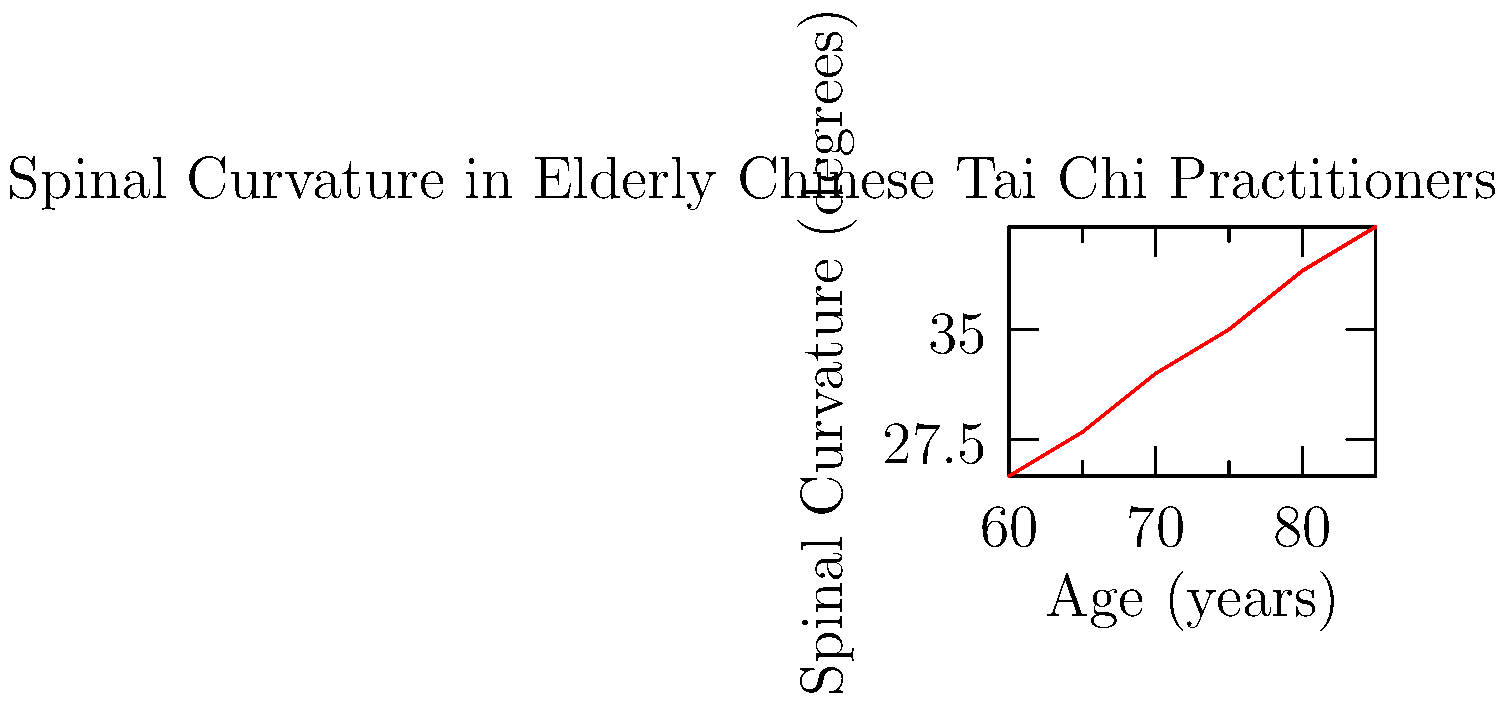Based on the graph showing the relationship between age and spinal curvature in elderly Chinese Tai Chi practitioners, what is the approximate rate of increase in spinal curvature per year? This data highlights the importance of traditional Chinese practices in maintaining health for our aging population. To calculate the rate of increase in spinal curvature per year:

1. Identify the change in spinal curvature:
   Final curvature (at 85 years): 42°
   Initial curvature (at 60 years): 25°
   Total change: 42° - 25° = 17°

2. Identify the time span:
   85 years - 60 years = 25 years

3. Calculate the rate of increase:
   Rate = Change in curvature / Time span
   Rate = 17° / 25 years
   Rate = 0.68° per year

Therefore, the spinal curvature increases by approximately 0.68° per year in elderly Chinese Tai Chi practitioners.

This relatively low rate of increase demonstrates the effectiveness of Tai Chi, a traditional Chinese practice, in maintaining spinal health among our elderly citizens, showcasing the wisdom of our cultural heritage in promoting health and longevity.
Answer: 0.68° per year 